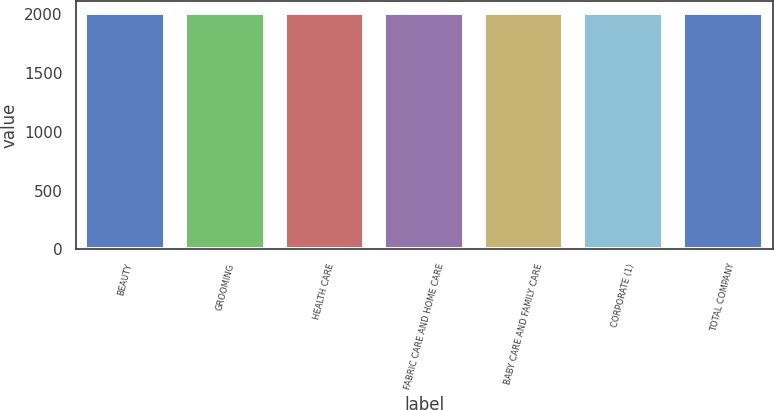Convert chart. <chart><loc_0><loc_0><loc_500><loc_500><bar_chart><fcel>BEAUTY<fcel>GROOMING<fcel>HEALTH CARE<fcel>FABRIC CARE AND HOME CARE<fcel>BABY CARE AND FAMILY CARE<fcel>CORPORATE (1)<fcel>TOTAL COMPANY<nl><fcel>2012<fcel>2012.1<fcel>2012.2<fcel>2012.3<fcel>2012.4<fcel>2012.5<fcel>2012.6<nl></chart> 